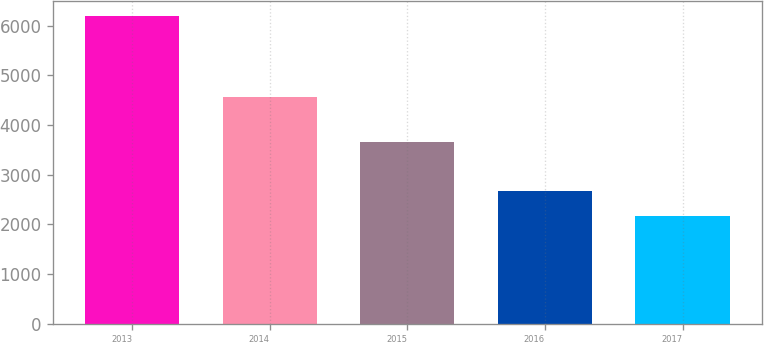Convert chart. <chart><loc_0><loc_0><loc_500><loc_500><bar_chart><fcel>2013<fcel>2014<fcel>2015<fcel>2016<fcel>2017<nl><fcel>6194<fcel>4556<fcel>3651<fcel>2662<fcel>2169<nl></chart> 